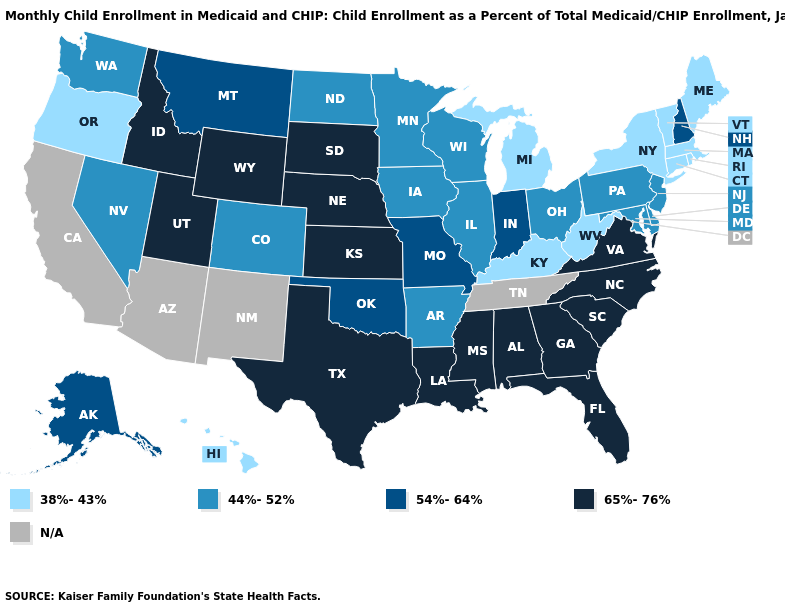Does Louisiana have the highest value in the South?
Write a very short answer. Yes. Which states hav the highest value in the West?
Be succinct. Idaho, Utah, Wyoming. What is the highest value in the Northeast ?
Be succinct. 54%-64%. Name the states that have a value in the range 38%-43%?
Be succinct. Connecticut, Hawaii, Kentucky, Maine, Massachusetts, Michigan, New York, Oregon, Rhode Island, Vermont, West Virginia. Does the map have missing data?
Concise answer only. Yes. Does Missouri have the highest value in the USA?
Give a very brief answer. No. Name the states that have a value in the range 44%-52%?
Be succinct. Arkansas, Colorado, Delaware, Illinois, Iowa, Maryland, Minnesota, Nevada, New Jersey, North Dakota, Ohio, Pennsylvania, Washington, Wisconsin. What is the value of Florida?
Give a very brief answer. 65%-76%. What is the highest value in the MidWest ?
Write a very short answer. 65%-76%. Name the states that have a value in the range 44%-52%?
Concise answer only. Arkansas, Colorado, Delaware, Illinois, Iowa, Maryland, Minnesota, Nevada, New Jersey, North Dakota, Ohio, Pennsylvania, Washington, Wisconsin. Does the map have missing data?
Give a very brief answer. Yes. What is the value of Kansas?
Keep it brief. 65%-76%. Which states have the lowest value in the Northeast?
Quick response, please. Connecticut, Maine, Massachusetts, New York, Rhode Island, Vermont. Does Mississippi have the highest value in the USA?
Be succinct. Yes. 